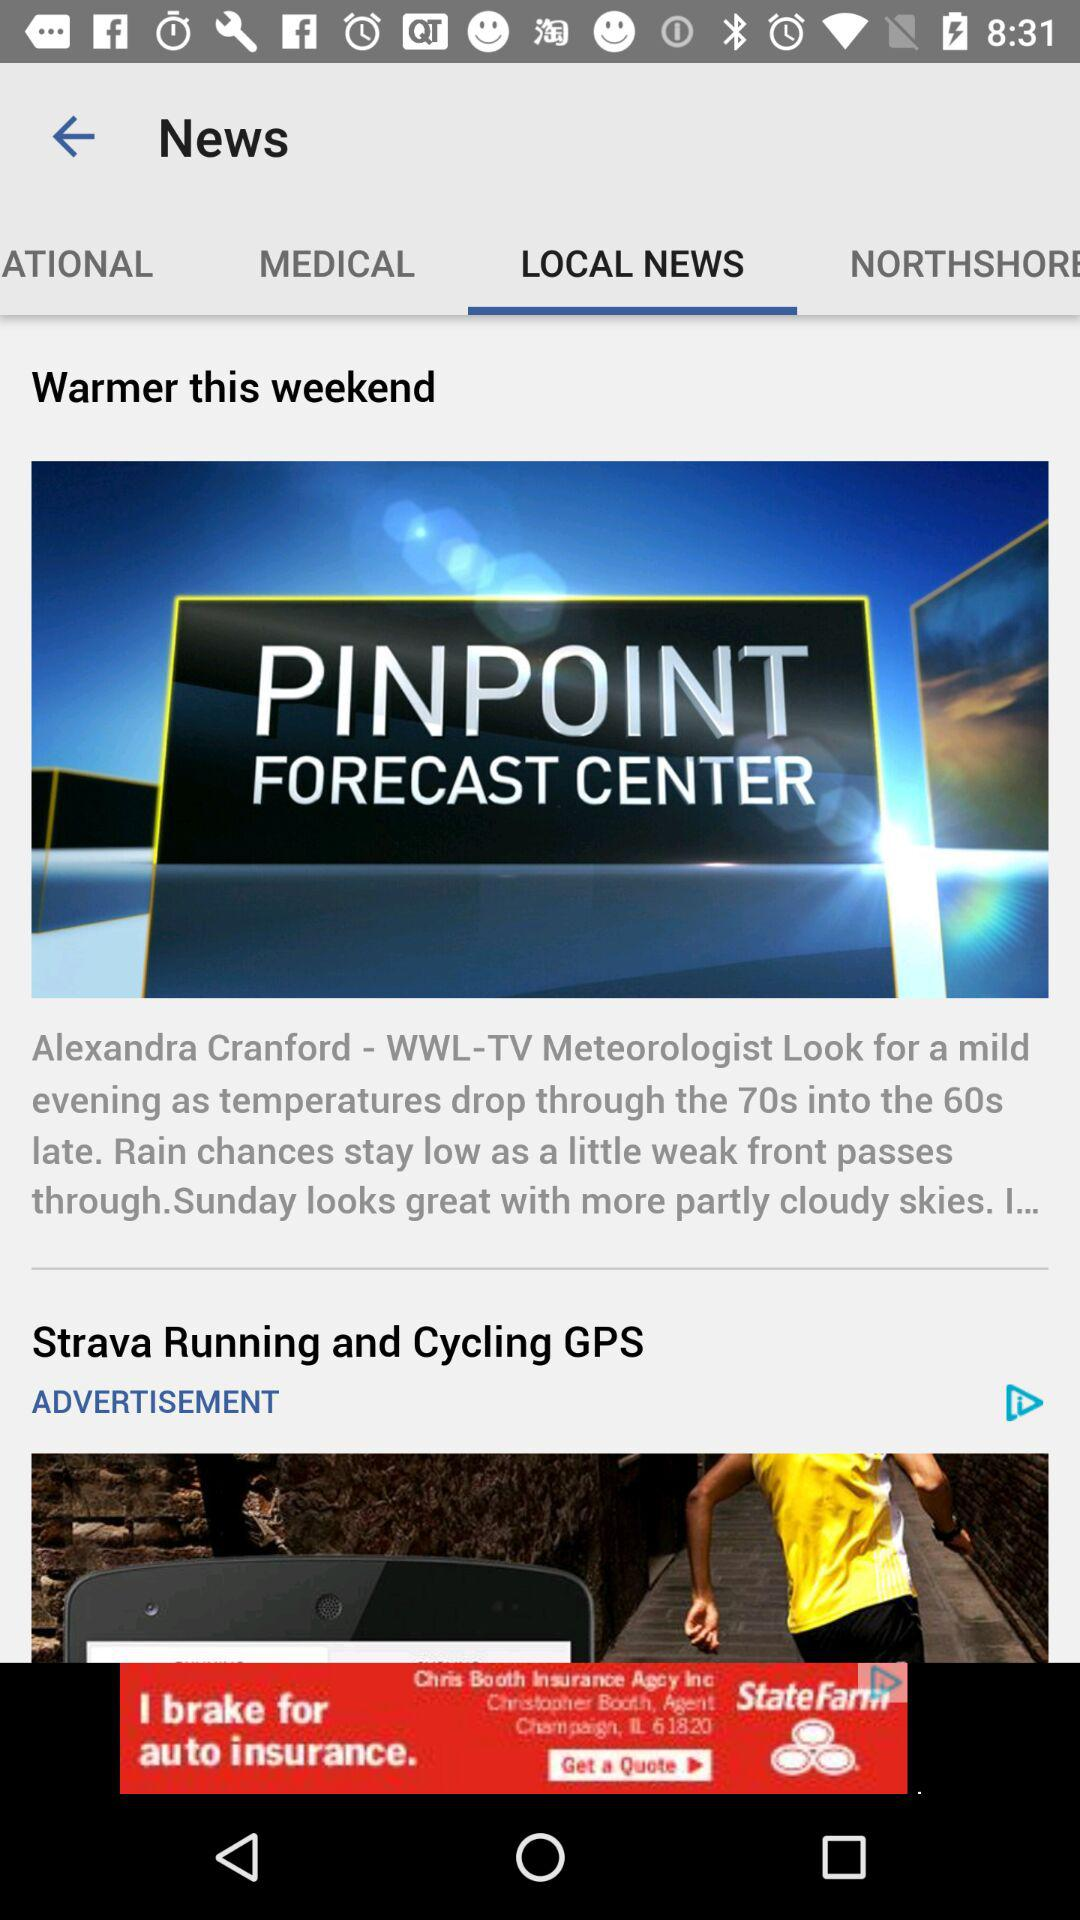Which tab is currently selected? The selected tab is "LOCAL NEWS". 